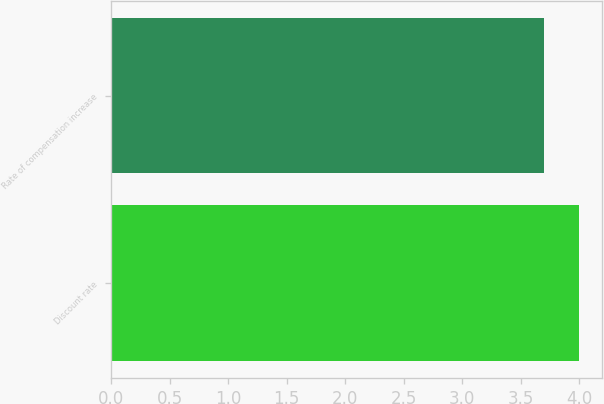Convert chart to OTSL. <chart><loc_0><loc_0><loc_500><loc_500><bar_chart><fcel>Discount rate<fcel>Rate of compensation increase<nl><fcel>4<fcel>3.7<nl></chart> 